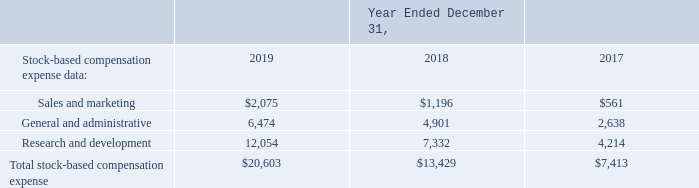Note 15. Stock-Based Compensation
Stock-based compensation expense is included in the following line items in the consolidated statements of operations (in thousands):
What was the amount of sales and marketing in 2019?
Answer scale should be: thousand. 2,075. What was the General and administrative in 2018?
Answer scale should be: thousand. 4,901. What was the Research and development in 2017?
Answer scale should be: thousand. 4,214. What was the change in the Sales and marketing between 2018 and 2019?
Answer scale should be: thousand. 2,075-1,196
Answer: 879. How many years did General and administrative exceed $4,000 thousand? 2019##2018
Answer: 2. What was the percentage change in the Total stock-based compensation expense between 2017 and 2018?
Answer scale should be: percent. (13,429-7,413)/7,413
Answer: 81.15. 